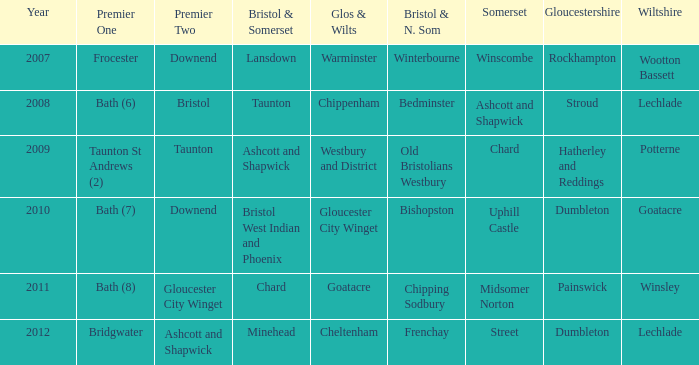Write the full table. {'header': ['Year', 'Premier One', 'Premier Two', 'Bristol & Somerset', 'Glos & Wilts', 'Bristol & N. Som', 'Somerset', 'Gloucestershire', 'Wiltshire'], 'rows': [['2007', 'Frocester', 'Downend', 'Lansdown', 'Warminster', 'Winterbourne', 'Winscombe', 'Rockhampton', 'Wootton Bassett'], ['2008', 'Bath (6)', 'Bristol', 'Taunton', 'Chippenham', 'Bedminster', 'Ashcott and Shapwick', 'Stroud', 'Lechlade'], ['2009', 'Taunton St Andrews (2)', 'Taunton', 'Ashcott and Shapwick', 'Westbury and District', 'Old Bristolians Westbury', 'Chard', 'Hatherley and Reddings', 'Potterne'], ['2010', 'Bath (7)', 'Downend', 'Bristol West Indian and Phoenix', 'Gloucester City Winget', 'Bishopston', 'Uphill Castle', 'Dumbleton', 'Goatacre'], ['2011', 'Bath (8)', 'Gloucester City Winget', 'Chard', 'Goatacre', 'Chipping Sodbury', 'Midsomer Norton', 'Painswick', 'Winsley'], ['2012', 'Bridgwater', 'Ashcott and Shapwick', 'Minehead', 'Cheltenham', 'Frenchay', 'Street', 'Dumbleton', 'Lechlade']]} How many instances is gloucestershire in painswick? 1.0. 